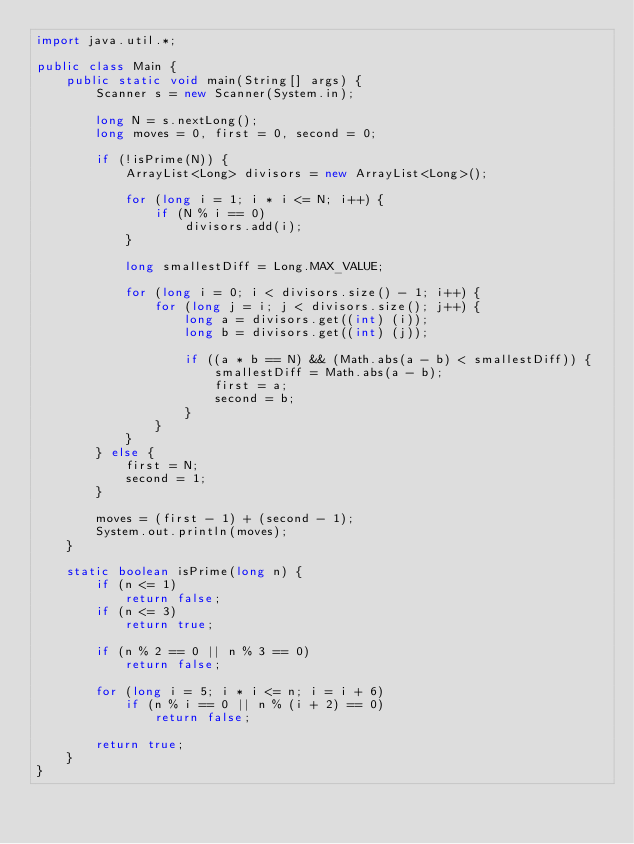<code> <loc_0><loc_0><loc_500><loc_500><_Java_>import java.util.*;

public class Main {
    public static void main(String[] args) {
        Scanner s = new Scanner(System.in);

        long N = s.nextLong();
        long moves = 0, first = 0, second = 0;

        if (!isPrime(N)) {
            ArrayList<Long> divisors = new ArrayList<Long>();
            
            for (long i = 1; i * i <= N; i++) {
                if (N % i == 0)
                    divisors.add(i);
            }

            long smallestDiff = Long.MAX_VALUE;

            for (long i = 0; i < divisors.size() - 1; i++) {
                for (long j = i; j < divisors.size(); j++) {
                    long a = divisors.get((int) (i));
                    long b = divisors.get((int) (j));

                    if ((a * b == N) && (Math.abs(a - b) < smallestDiff)) {
                        smallestDiff = Math.abs(a - b);
                        first = a;
                        second = b;
                    }
                }
            }
        } else {
            first = N;
            second = 1;
        }

        moves = (first - 1) + (second - 1);
        System.out.println(moves);
    }

    static boolean isPrime(long n) {
        if (n <= 1)
            return false;
        if (n <= 3)
            return true;

        if (n % 2 == 0 || n % 3 == 0)
            return false;

        for (long i = 5; i * i <= n; i = i + 6)
            if (n % i == 0 || n % (i + 2) == 0)
                return false;

        return true;
    }
}</code> 